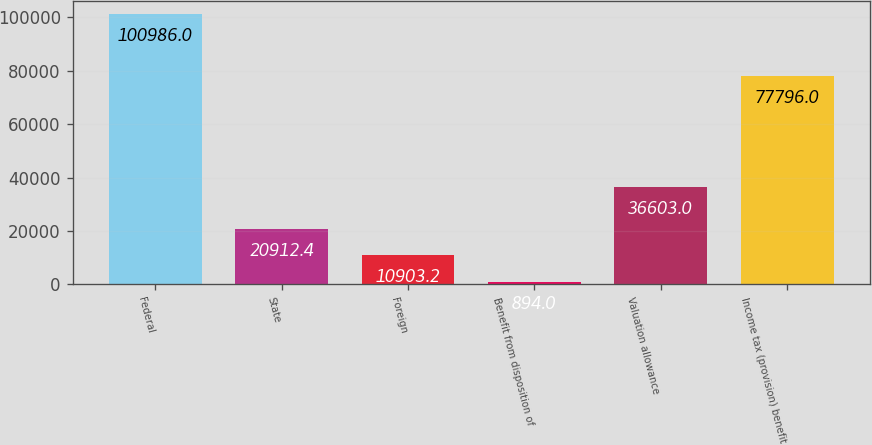Convert chart to OTSL. <chart><loc_0><loc_0><loc_500><loc_500><bar_chart><fcel>Federal<fcel>State<fcel>Foreign<fcel>Benefit from disposition of<fcel>Valuation allowance<fcel>Income tax (provision) benefit<nl><fcel>100986<fcel>20912.4<fcel>10903.2<fcel>894<fcel>36603<fcel>77796<nl></chart> 